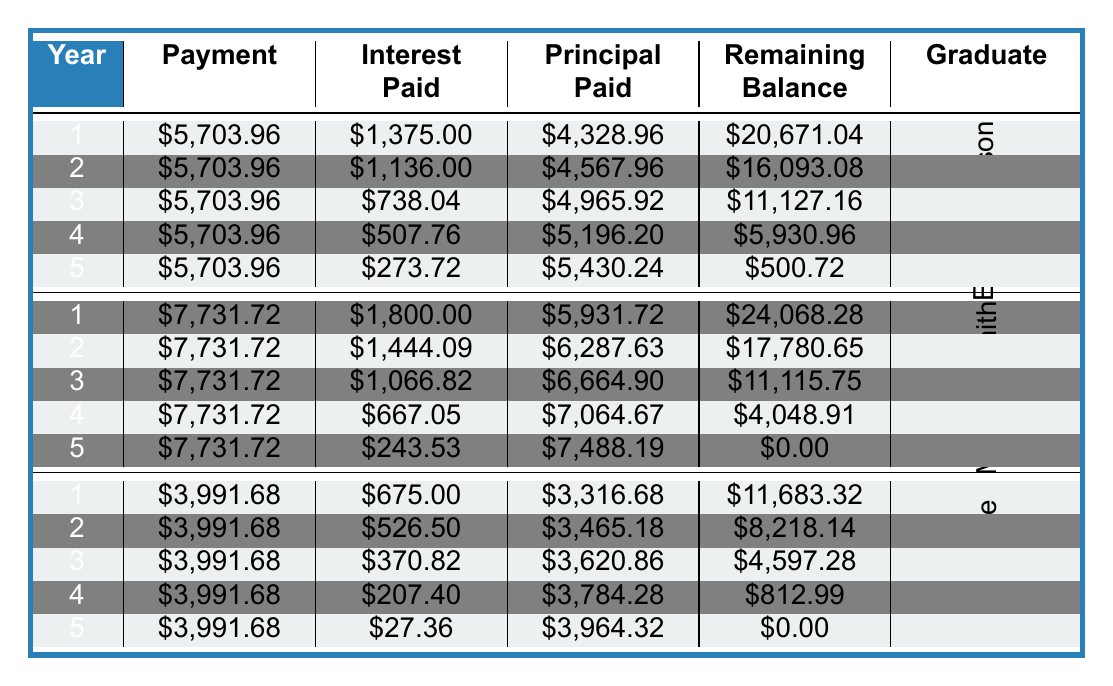What is the total payment made by Emily Johnson over the 5 years? The total payment for Emily is listed in the table under the Total Payment column, where it shows \$28,645.20 as her total payment over the five years.
Answer: 28645.20 What was Michael Smith's remaining balance after the first year? Referring to the first-year payment schedule for Michael Smith, the remaining balance after the first year is \$24,068.28.
Answer: 24068.28 Is Sarah Lee's total interest paid greater than \$4,500? The total interest paid by Sarah Lee is \$4,548.40, which is indeed greater than \$4,500. Thus, the answer is yes.
Answer: Yes What is the average interest paid per year by Michael Smith? To find the average interest paid, sum the interest paid each year (1,800.00 + 1,444.09 + 1,066.82 + 667.05 + 243.53 = 5,221.49) and divide by the number of years (5): 5,221.49 / 5 = 1,044.30.
Answer: 1044.30 What is the total principal paid by Emily Johnson in the 5th year? In the payment schedule for Emily Johnson, the principal paid in the 5th year is \$5,430.24.
Answer: 5430.24 Did any graduate pay off their loan completely in less than 5 years? Looking at the remaining balance of all graduates, both Emily and Sarah Lee still had balances after 5 years, but Michael Smith completed his payments leaving a remaining balance of \$0 after year 5. Therefore, the answer is no.
Answer: No What was the highest monthly payment amount among the graduates? The monthly payments can be compared, where Michael Smith's monthly payment of \$644.31 is higher than both Emily Johnson's (\$477.42) and Sarah Lee's (\$332.64). Thus, the maximum amount is \$644.31.
Answer: 644.31 What is the difference in total payments between Emily Johnson and Sarah Lee? To find the difference, subtract Sarah Lee's total payment (\$19,958.40) from Emily Johnson's total payment (\$28,645.20): 28,645.20 - 19,958.40 = 8,686.80.
Answer: 8686.80 